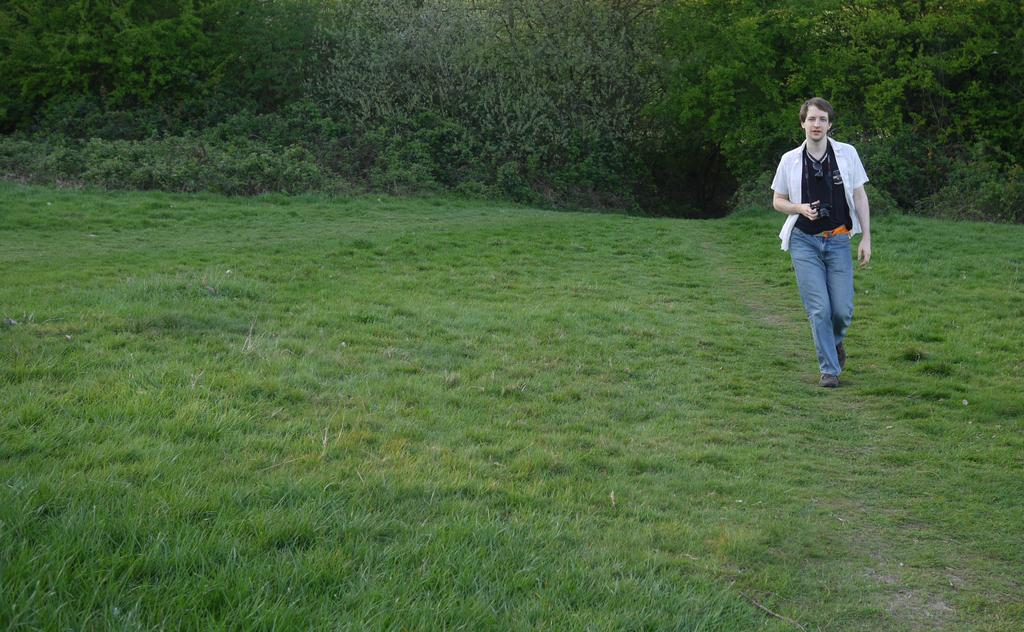What is the main subject of the image? There is a person in the image. What is the person doing in the image? The person is walking on the ground. What is the person wearing in the image? The person is wearing a white shirt and blue jeans. What type of natural environment is visible in the image? There are trees and grass visible in the image. What type of faucet can be seen in the image? There is no faucet present in the image. How are the waves affecting the person's walk in the image? There are no waves present in the image; it is set on the ground with trees and grass. 